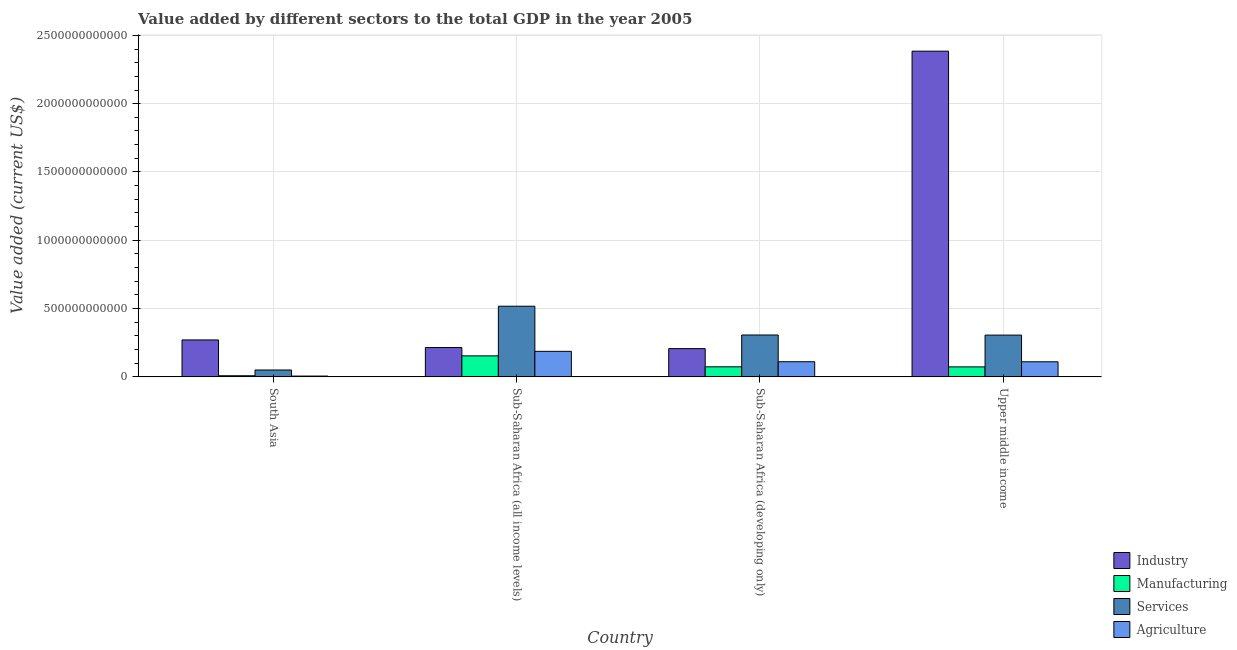How many groups of bars are there?
Give a very brief answer. 4. Are the number of bars per tick equal to the number of legend labels?
Make the answer very short. Yes. Are the number of bars on each tick of the X-axis equal?
Make the answer very short. Yes. How many bars are there on the 4th tick from the right?
Offer a very short reply. 4. What is the label of the 4th group of bars from the left?
Keep it short and to the point. Upper middle income. In how many cases, is the number of bars for a given country not equal to the number of legend labels?
Provide a succinct answer. 0. What is the value added by manufacturing sector in Sub-Saharan Africa (all income levels)?
Your answer should be very brief. 1.54e+11. Across all countries, what is the maximum value added by industrial sector?
Ensure brevity in your answer.  2.38e+12. Across all countries, what is the minimum value added by services sector?
Ensure brevity in your answer.  5.03e+1. In which country was the value added by services sector maximum?
Give a very brief answer. Sub-Saharan Africa (all income levels). In which country was the value added by manufacturing sector minimum?
Offer a terse response. South Asia. What is the total value added by industrial sector in the graph?
Offer a very short reply. 3.08e+12. What is the difference between the value added by manufacturing sector in South Asia and that in Sub-Saharan Africa (developing only)?
Provide a short and direct response. -6.55e+1. What is the difference between the value added by industrial sector in Sub-Saharan Africa (all income levels) and the value added by agricultural sector in Sub-Saharan Africa (developing only)?
Offer a terse response. 1.04e+11. What is the average value added by industrial sector per country?
Your answer should be compact. 7.69e+11. What is the difference between the value added by agricultural sector and value added by services sector in Sub-Saharan Africa (all income levels)?
Provide a succinct answer. -3.30e+11. In how many countries, is the value added by manufacturing sector greater than 2200000000000 US$?
Provide a succinct answer. 0. What is the ratio of the value added by agricultural sector in Sub-Saharan Africa (all income levels) to that in Upper middle income?
Offer a terse response. 1.69. Is the difference between the value added by services sector in South Asia and Sub-Saharan Africa (all income levels) greater than the difference between the value added by industrial sector in South Asia and Sub-Saharan Africa (all income levels)?
Provide a short and direct response. No. What is the difference between the highest and the second highest value added by manufacturing sector?
Your answer should be compact. 8.00e+1. What is the difference between the highest and the lowest value added by agricultural sector?
Provide a short and direct response. 1.81e+11. In how many countries, is the value added by services sector greater than the average value added by services sector taken over all countries?
Your answer should be very brief. 3. Is the sum of the value added by agricultural sector in Sub-Saharan Africa (all income levels) and Upper middle income greater than the maximum value added by services sector across all countries?
Ensure brevity in your answer.  No. Is it the case that in every country, the sum of the value added by manufacturing sector and value added by industrial sector is greater than the sum of value added by agricultural sector and value added by services sector?
Your answer should be compact. No. What does the 4th bar from the left in South Asia represents?
Make the answer very short. Agriculture. What does the 2nd bar from the right in South Asia represents?
Provide a short and direct response. Services. Is it the case that in every country, the sum of the value added by industrial sector and value added by manufacturing sector is greater than the value added by services sector?
Your answer should be very brief. No. How many bars are there?
Keep it short and to the point. 16. What is the difference between two consecutive major ticks on the Y-axis?
Make the answer very short. 5.00e+11. Are the values on the major ticks of Y-axis written in scientific E-notation?
Provide a succinct answer. No. Does the graph contain any zero values?
Ensure brevity in your answer.  No. Does the graph contain grids?
Your answer should be very brief. Yes. How many legend labels are there?
Offer a very short reply. 4. How are the legend labels stacked?
Your answer should be compact. Vertical. What is the title of the graph?
Offer a terse response. Value added by different sectors to the total GDP in the year 2005. Does "Secondary general" appear as one of the legend labels in the graph?
Your response must be concise. No. What is the label or title of the X-axis?
Provide a short and direct response. Country. What is the label or title of the Y-axis?
Your answer should be compact. Value added (current US$). What is the Value added (current US$) of Industry in South Asia?
Your response must be concise. 2.70e+11. What is the Value added (current US$) in Manufacturing in South Asia?
Offer a very short reply. 8.22e+09. What is the Value added (current US$) in Services in South Asia?
Offer a very short reply. 5.03e+1. What is the Value added (current US$) of Agriculture in South Asia?
Provide a succinct answer. 5.90e+09. What is the Value added (current US$) in Industry in Sub-Saharan Africa (all income levels)?
Offer a very short reply. 2.15e+11. What is the Value added (current US$) of Manufacturing in Sub-Saharan Africa (all income levels)?
Provide a short and direct response. 1.54e+11. What is the Value added (current US$) of Services in Sub-Saharan Africa (all income levels)?
Ensure brevity in your answer.  5.17e+11. What is the Value added (current US$) of Agriculture in Sub-Saharan Africa (all income levels)?
Provide a succinct answer. 1.87e+11. What is the Value added (current US$) in Industry in Sub-Saharan Africa (developing only)?
Provide a short and direct response. 2.07e+11. What is the Value added (current US$) of Manufacturing in Sub-Saharan Africa (developing only)?
Your answer should be compact. 7.37e+1. What is the Value added (current US$) in Services in Sub-Saharan Africa (developing only)?
Your answer should be compact. 3.07e+11. What is the Value added (current US$) of Agriculture in Sub-Saharan Africa (developing only)?
Offer a very short reply. 1.11e+11. What is the Value added (current US$) of Industry in Upper middle income?
Give a very brief answer. 2.38e+12. What is the Value added (current US$) of Manufacturing in Upper middle income?
Your answer should be very brief. 7.31e+1. What is the Value added (current US$) in Services in Upper middle income?
Ensure brevity in your answer.  3.06e+11. What is the Value added (current US$) of Agriculture in Upper middle income?
Provide a short and direct response. 1.11e+11. Across all countries, what is the maximum Value added (current US$) of Industry?
Provide a succinct answer. 2.38e+12. Across all countries, what is the maximum Value added (current US$) in Manufacturing?
Ensure brevity in your answer.  1.54e+11. Across all countries, what is the maximum Value added (current US$) in Services?
Give a very brief answer. 5.17e+11. Across all countries, what is the maximum Value added (current US$) in Agriculture?
Your response must be concise. 1.87e+11. Across all countries, what is the minimum Value added (current US$) in Industry?
Keep it short and to the point. 2.07e+11. Across all countries, what is the minimum Value added (current US$) of Manufacturing?
Offer a very short reply. 8.22e+09. Across all countries, what is the minimum Value added (current US$) in Services?
Offer a very short reply. 5.03e+1. Across all countries, what is the minimum Value added (current US$) in Agriculture?
Keep it short and to the point. 5.90e+09. What is the total Value added (current US$) in Industry in the graph?
Offer a very short reply. 3.08e+12. What is the total Value added (current US$) in Manufacturing in the graph?
Provide a succinct answer. 3.09e+11. What is the total Value added (current US$) in Services in the graph?
Provide a succinct answer. 1.18e+12. What is the total Value added (current US$) in Agriculture in the graph?
Offer a terse response. 4.14e+11. What is the difference between the Value added (current US$) in Industry in South Asia and that in Sub-Saharan Africa (all income levels)?
Ensure brevity in your answer.  5.56e+1. What is the difference between the Value added (current US$) of Manufacturing in South Asia and that in Sub-Saharan Africa (all income levels)?
Your response must be concise. -1.46e+11. What is the difference between the Value added (current US$) of Services in South Asia and that in Sub-Saharan Africa (all income levels)?
Your answer should be compact. -4.67e+11. What is the difference between the Value added (current US$) of Agriculture in South Asia and that in Sub-Saharan Africa (all income levels)?
Give a very brief answer. -1.81e+11. What is the difference between the Value added (current US$) of Industry in South Asia and that in Sub-Saharan Africa (developing only)?
Offer a very short reply. 6.35e+1. What is the difference between the Value added (current US$) in Manufacturing in South Asia and that in Sub-Saharan Africa (developing only)?
Offer a terse response. -6.55e+1. What is the difference between the Value added (current US$) in Services in South Asia and that in Sub-Saharan Africa (developing only)?
Provide a succinct answer. -2.56e+11. What is the difference between the Value added (current US$) of Agriculture in South Asia and that in Sub-Saharan Africa (developing only)?
Provide a short and direct response. -1.05e+11. What is the difference between the Value added (current US$) in Industry in South Asia and that in Upper middle income?
Keep it short and to the point. -2.11e+12. What is the difference between the Value added (current US$) of Manufacturing in South Asia and that in Upper middle income?
Your response must be concise. -6.49e+1. What is the difference between the Value added (current US$) in Services in South Asia and that in Upper middle income?
Provide a succinct answer. -2.55e+11. What is the difference between the Value added (current US$) in Agriculture in South Asia and that in Upper middle income?
Offer a terse response. -1.05e+11. What is the difference between the Value added (current US$) in Industry in Sub-Saharan Africa (all income levels) and that in Sub-Saharan Africa (developing only)?
Give a very brief answer. 7.93e+09. What is the difference between the Value added (current US$) of Manufacturing in Sub-Saharan Africa (all income levels) and that in Sub-Saharan Africa (developing only)?
Your response must be concise. 8.00e+1. What is the difference between the Value added (current US$) in Services in Sub-Saharan Africa (all income levels) and that in Sub-Saharan Africa (developing only)?
Your response must be concise. 2.11e+11. What is the difference between the Value added (current US$) in Agriculture in Sub-Saharan Africa (all income levels) and that in Sub-Saharan Africa (developing only)?
Your answer should be compact. 7.61e+1. What is the difference between the Value added (current US$) of Industry in Sub-Saharan Africa (all income levels) and that in Upper middle income?
Keep it short and to the point. -2.17e+12. What is the difference between the Value added (current US$) of Manufacturing in Sub-Saharan Africa (all income levels) and that in Upper middle income?
Give a very brief answer. 8.06e+1. What is the difference between the Value added (current US$) in Services in Sub-Saharan Africa (all income levels) and that in Upper middle income?
Your answer should be very brief. 2.12e+11. What is the difference between the Value added (current US$) in Agriculture in Sub-Saharan Africa (all income levels) and that in Upper middle income?
Provide a short and direct response. 7.63e+1. What is the difference between the Value added (current US$) in Industry in Sub-Saharan Africa (developing only) and that in Upper middle income?
Your answer should be very brief. -2.18e+12. What is the difference between the Value added (current US$) of Manufacturing in Sub-Saharan Africa (developing only) and that in Upper middle income?
Keep it short and to the point. 6.05e+08. What is the difference between the Value added (current US$) of Services in Sub-Saharan Africa (developing only) and that in Upper middle income?
Your answer should be compact. 8.31e+08. What is the difference between the Value added (current US$) of Agriculture in Sub-Saharan Africa (developing only) and that in Upper middle income?
Provide a succinct answer. 2.47e+08. What is the difference between the Value added (current US$) of Industry in South Asia and the Value added (current US$) of Manufacturing in Sub-Saharan Africa (all income levels)?
Your answer should be very brief. 1.17e+11. What is the difference between the Value added (current US$) in Industry in South Asia and the Value added (current US$) in Services in Sub-Saharan Africa (all income levels)?
Ensure brevity in your answer.  -2.47e+11. What is the difference between the Value added (current US$) of Industry in South Asia and the Value added (current US$) of Agriculture in Sub-Saharan Africa (all income levels)?
Make the answer very short. 8.35e+1. What is the difference between the Value added (current US$) of Manufacturing in South Asia and the Value added (current US$) of Services in Sub-Saharan Africa (all income levels)?
Your answer should be compact. -5.09e+11. What is the difference between the Value added (current US$) of Manufacturing in South Asia and the Value added (current US$) of Agriculture in Sub-Saharan Africa (all income levels)?
Your answer should be compact. -1.79e+11. What is the difference between the Value added (current US$) in Services in South Asia and the Value added (current US$) in Agriculture in Sub-Saharan Africa (all income levels)?
Keep it short and to the point. -1.37e+11. What is the difference between the Value added (current US$) in Industry in South Asia and the Value added (current US$) in Manufacturing in Sub-Saharan Africa (developing only)?
Keep it short and to the point. 1.97e+11. What is the difference between the Value added (current US$) in Industry in South Asia and the Value added (current US$) in Services in Sub-Saharan Africa (developing only)?
Make the answer very short. -3.62e+1. What is the difference between the Value added (current US$) of Industry in South Asia and the Value added (current US$) of Agriculture in Sub-Saharan Africa (developing only)?
Your response must be concise. 1.60e+11. What is the difference between the Value added (current US$) of Manufacturing in South Asia and the Value added (current US$) of Services in Sub-Saharan Africa (developing only)?
Offer a terse response. -2.98e+11. What is the difference between the Value added (current US$) in Manufacturing in South Asia and the Value added (current US$) in Agriculture in Sub-Saharan Africa (developing only)?
Your answer should be very brief. -1.03e+11. What is the difference between the Value added (current US$) of Services in South Asia and the Value added (current US$) of Agriculture in Sub-Saharan Africa (developing only)?
Provide a succinct answer. -6.05e+1. What is the difference between the Value added (current US$) in Industry in South Asia and the Value added (current US$) in Manufacturing in Upper middle income?
Your answer should be compact. 1.97e+11. What is the difference between the Value added (current US$) of Industry in South Asia and the Value added (current US$) of Services in Upper middle income?
Provide a succinct answer. -3.53e+1. What is the difference between the Value added (current US$) in Industry in South Asia and the Value added (current US$) in Agriculture in Upper middle income?
Make the answer very short. 1.60e+11. What is the difference between the Value added (current US$) in Manufacturing in South Asia and the Value added (current US$) in Services in Upper middle income?
Your response must be concise. -2.98e+11. What is the difference between the Value added (current US$) in Manufacturing in South Asia and the Value added (current US$) in Agriculture in Upper middle income?
Provide a short and direct response. -1.02e+11. What is the difference between the Value added (current US$) of Services in South Asia and the Value added (current US$) of Agriculture in Upper middle income?
Provide a succinct answer. -6.02e+1. What is the difference between the Value added (current US$) in Industry in Sub-Saharan Africa (all income levels) and the Value added (current US$) in Manufacturing in Sub-Saharan Africa (developing only)?
Your answer should be very brief. 1.41e+11. What is the difference between the Value added (current US$) of Industry in Sub-Saharan Africa (all income levels) and the Value added (current US$) of Services in Sub-Saharan Africa (developing only)?
Keep it short and to the point. -9.18e+1. What is the difference between the Value added (current US$) in Industry in Sub-Saharan Africa (all income levels) and the Value added (current US$) in Agriculture in Sub-Saharan Africa (developing only)?
Provide a succinct answer. 1.04e+11. What is the difference between the Value added (current US$) in Manufacturing in Sub-Saharan Africa (all income levels) and the Value added (current US$) in Services in Sub-Saharan Africa (developing only)?
Make the answer very short. -1.53e+11. What is the difference between the Value added (current US$) of Manufacturing in Sub-Saharan Africa (all income levels) and the Value added (current US$) of Agriculture in Sub-Saharan Africa (developing only)?
Your answer should be compact. 4.29e+1. What is the difference between the Value added (current US$) of Services in Sub-Saharan Africa (all income levels) and the Value added (current US$) of Agriculture in Sub-Saharan Africa (developing only)?
Your answer should be compact. 4.06e+11. What is the difference between the Value added (current US$) in Industry in Sub-Saharan Africa (all income levels) and the Value added (current US$) in Manufacturing in Upper middle income?
Your answer should be very brief. 1.42e+11. What is the difference between the Value added (current US$) of Industry in Sub-Saharan Africa (all income levels) and the Value added (current US$) of Services in Upper middle income?
Your response must be concise. -9.09e+1. What is the difference between the Value added (current US$) in Industry in Sub-Saharan Africa (all income levels) and the Value added (current US$) in Agriculture in Upper middle income?
Your response must be concise. 1.04e+11. What is the difference between the Value added (current US$) of Manufacturing in Sub-Saharan Africa (all income levels) and the Value added (current US$) of Services in Upper middle income?
Give a very brief answer. -1.52e+11. What is the difference between the Value added (current US$) of Manufacturing in Sub-Saharan Africa (all income levels) and the Value added (current US$) of Agriculture in Upper middle income?
Provide a short and direct response. 4.32e+1. What is the difference between the Value added (current US$) in Services in Sub-Saharan Africa (all income levels) and the Value added (current US$) in Agriculture in Upper middle income?
Your answer should be very brief. 4.07e+11. What is the difference between the Value added (current US$) in Industry in Sub-Saharan Africa (developing only) and the Value added (current US$) in Manufacturing in Upper middle income?
Provide a succinct answer. 1.34e+11. What is the difference between the Value added (current US$) in Industry in Sub-Saharan Africa (developing only) and the Value added (current US$) in Services in Upper middle income?
Your answer should be very brief. -9.89e+1. What is the difference between the Value added (current US$) in Industry in Sub-Saharan Africa (developing only) and the Value added (current US$) in Agriculture in Upper middle income?
Your answer should be very brief. 9.63e+1. What is the difference between the Value added (current US$) in Manufacturing in Sub-Saharan Africa (developing only) and the Value added (current US$) in Services in Upper middle income?
Your answer should be compact. -2.32e+11. What is the difference between the Value added (current US$) of Manufacturing in Sub-Saharan Africa (developing only) and the Value added (current US$) of Agriculture in Upper middle income?
Your answer should be compact. -3.69e+1. What is the difference between the Value added (current US$) in Services in Sub-Saharan Africa (developing only) and the Value added (current US$) in Agriculture in Upper middle income?
Provide a short and direct response. 1.96e+11. What is the average Value added (current US$) of Industry per country?
Offer a terse response. 7.69e+11. What is the average Value added (current US$) in Manufacturing per country?
Give a very brief answer. 7.72e+1. What is the average Value added (current US$) in Services per country?
Provide a succinct answer. 2.95e+11. What is the average Value added (current US$) in Agriculture per country?
Offer a terse response. 1.04e+11. What is the difference between the Value added (current US$) in Industry and Value added (current US$) in Manufacturing in South Asia?
Provide a short and direct response. 2.62e+11. What is the difference between the Value added (current US$) in Industry and Value added (current US$) in Services in South Asia?
Offer a terse response. 2.20e+11. What is the difference between the Value added (current US$) of Industry and Value added (current US$) of Agriculture in South Asia?
Give a very brief answer. 2.65e+11. What is the difference between the Value added (current US$) in Manufacturing and Value added (current US$) in Services in South Asia?
Provide a succinct answer. -4.21e+1. What is the difference between the Value added (current US$) of Manufacturing and Value added (current US$) of Agriculture in South Asia?
Provide a short and direct response. 2.32e+09. What is the difference between the Value added (current US$) in Services and Value added (current US$) in Agriculture in South Asia?
Give a very brief answer. 4.44e+1. What is the difference between the Value added (current US$) in Industry and Value added (current US$) in Manufacturing in Sub-Saharan Africa (all income levels)?
Your response must be concise. 6.10e+1. What is the difference between the Value added (current US$) of Industry and Value added (current US$) of Services in Sub-Saharan Africa (all income levels)?
Keep it short and to the point. -3.02e+11. What is the difference between the Value added (current US$) of Industry and Value added (current US$) of Agriculture in Sub-Saharan Africa (all income levels)?
Ensure brevity in your answer.  2.79e+1. What is the difference between the Value added (current US$) of Manufacturing and Value added (current US$) of Services in Sub-Saharan Africa (all income levels)?
Give a very brief answer. -3.64e+11. What is the difference between the Value added (current US$) of Manufacturing and Value added (current US$) of Agriculture in Sub-Saharan Africa (all income levels)?
Give a very brief answer. -3.32e+1. What is the difference between the Value added (current US$) of Services and Value added (current US$) of Agriculture in Sub-Saharan Africa (all income levels)?
Provide a short and direct response. 3.30e+11. What is the difference between the Value added (current US$) in Industry and Value added (current US$) in Manufacturing in Sub-Saharan Africa (developing only)?
Provide a short and direct response. 1.33e+11. What is the difference between the Value added (current US$) in Industry and Value added (current US$) in Services in Sub-Saharan Africa (developing only)?
Provide a succinct answer. -9.97e+1. What is the difference between the Value added (current US$) in Industry and Value added (current US$) in Agriculture in Sub-Saharan Africa (developing only)?
Make the answer very short. 9.61e+1. What is the difference between the Value added (current US$) in Manufacturing and Value added (current US$) in Services in Sub-Saharan Africa (developing only)?
Provide a short and direct response. -2.33e+11. What is the difference between the Value added (current US$) in Manufacturing and Value added (current US$) in Agriculture in Sub-Saharan Africa (developing only)?
Your response must be concise. -3.71e+1. What is the difference between the Value added (current US$) in Services and Value added (current US$) in Agriculture in Sub-Saharan Africa (developing only)?
Provide a succinct answer. 1.96e+11. What is the difference between the Value added (current US$) of Industry and Value added (current US$) of Manufacturing in Upper middle income?
Provide a short and direct response. 2.31e+12. What is the difference between the Value added (current US$) in Industry and Value added (current US$) in Services in Upper middle income?
Keep it short and to the point. 2.08e+12. What is the difference between the Value added (current US$) of Industry and Value added (current US$) of Agriculture in Upper middle income?
Your answer should be compact. 2.27e+12. What is the difference between the Value added (current US$) in Manufacturing and Value added (current US$) in Services in Upper middle income?
Your answer should be very brief. -2.33e+11. What is the difference between the Value added (current US$) of Manufacturing and Value added (current US$) of Agriculture in Upper middle income?
Make the answer very short. -3.75e+1. What is the difference between the Value added (current US$) in Services and Value added (current US$) in Agriculture in Upper middle income?
Make the answer very short. 1.95e+11. What is the ratio of the Value added (current US$) in Industry in South Asia to that in Sub-Saharan Africa (all income levels)?
Your answer should be very brief. 1.26. What is the ratio of the Value added (current US$) of Manufacturing in South Asia to that in Sub-Saharan Africa (all income levels)?
Your answer should be very brief. 0.05. What is the ratio of the Value added (current US$) in Services in South Asia to that in Sub-Saharan Africa (all income levels)?
Provide a short and direct response. 0.1. What is the ratio of the Value added (current US$) in Agriculture in South Asia to that in Sub-Saharan Africa (all income levels)?
Offer a very short reply. 0.03. What is the ratio of the Value added (current US$) in Industry in South Asia to that in Sub-Saharan Africa (developing only)?
Provide a succinct answer. 1.31. What is the ratio of the Value added (current US$) of Manufacturing in South Asia to that in Sub-Saharan Africa (developing only)?
Your answer should be very brief. 0.11. What is the ratio of the Value added (current US$) in Services in South Asia to that in Sub-Saharan Africa (developing only)?
Your answer should be very brief. 0.16. What is the ratio of the Value added (current US$) of Agriculture in South Asia to that in Sub-Saharan Africa (developing only)?
Offer a terse response. 0.05. What is the ratio of the Value added (current US$) of Industry in South Asia to that in Upper middle income?
Your answer should be compact. 0.11. What is the ratio of the Value added (current US$) in Manufacturing in South Asia to that in Upper middle income?
Keep it short and to the point. 0.11. What is the ratio of the Value added (current US$) in Services in South Asia to that in Upper middle income?
Your response must be concise. 0.16. What is the ratio of the Value added (current US$) of Agriculture in South Asia to that in Upper middle income?
Your answer should be very brief. 0.05. What is the ratio of the Value added (current US$) of Industry in Sub-Saharan Africa (all income levels) to that in Sub-Saharan Africa (developing only)?
Ensure brevity in your answer.  1.04. What is the ratio of the Value added (current US$) of Manufacturing in Sub-Saharan Africa (all income levels) to that in Sub-Saharan Africa (developing only)?
Make the answer very short. 2.09. What is the ratio of the Value added (current US$) in Services in Sub-Saharan Africa (all income levels) to that in Sub-Saharan Africa (developing only)?
Ensure brevity in your answer.  1.69. What is the ratio of the Value added (current US$) in Agriculture in Sub-Saharan Africa (all income levels) to that in Sub-Saharan Africa (developing only)?
Offer a very short reply. 1.69. What is the ratio of the Value added (current US$) of Industry in Sub-Saharan Africa (all income levels) to that in Upper middle income?
Provide a short and direct response. 0.09. What is the ratio of the Value added (current US$) in Manufacturing in Sub-Saharan Africa (all income levels) to that in Upper middle income?
Provide a short and direct response. 2.1. What is the ratio of the Value added (current US$) of Services in Sub-Saharan Africa (all income levels) to that in Upper middle income?
Your answer should be very brief. 1.69. What is the ratio of the Value added (current US$) in Agriculture in Sub-Saharan Africa (all income levels) to that in Upper middle income?
Provide a succinct answer. 1.69. What is the ratio of the Value added (current US$) in Industry in Sub-Saharan Africa (developing only) to that in Upper middle income?
Offer a very short reply. 0.09. What is the ratio of the Value added (current US$) in Manufacturing in Sub-Saharan Africa (developing only) to that in Upper middle income?
Your answer should be very brief. 1.01. What is the ratio of the Value added (current US$) in Services in Sub-Saharan Africa (developing only) to that in Upper middle income?
Give a very brief answer. 1. What is the difference between the highest and the second highest Value added (current US$) in Industry?
Provide a short and direct response. 2.11e+12. What is the difference between the highest and the second highest Value added (current US$) in Manufacturing?
Provide a succinct answer. 8.00e+1. What is the difference between the highest and the second highest Value added (current US$) in Services?
Your answer should be compact. 2.11e+11. What is the difference between the highest and the second highest Value added (current US$) in Agriculture?
Make the answer very short. 7.61e+1. What is the difference between the highest and the lowest Value added (current US$) of Industry?
Your response must be concise. 2.18e+12. What is the difference between the highest and the lowest Value added (current US$) of Manufacturing?
Give a very brief answer. 1.46e+11. What is the difference between the highest and the lowest Value added (current US$) of Services?
Keep it short and to the point. 4.67e+11. What is the difference between the highest and the lowest Value added (current US$) in Agriculture?
Your answer should be very brief. 1.81e+11. 